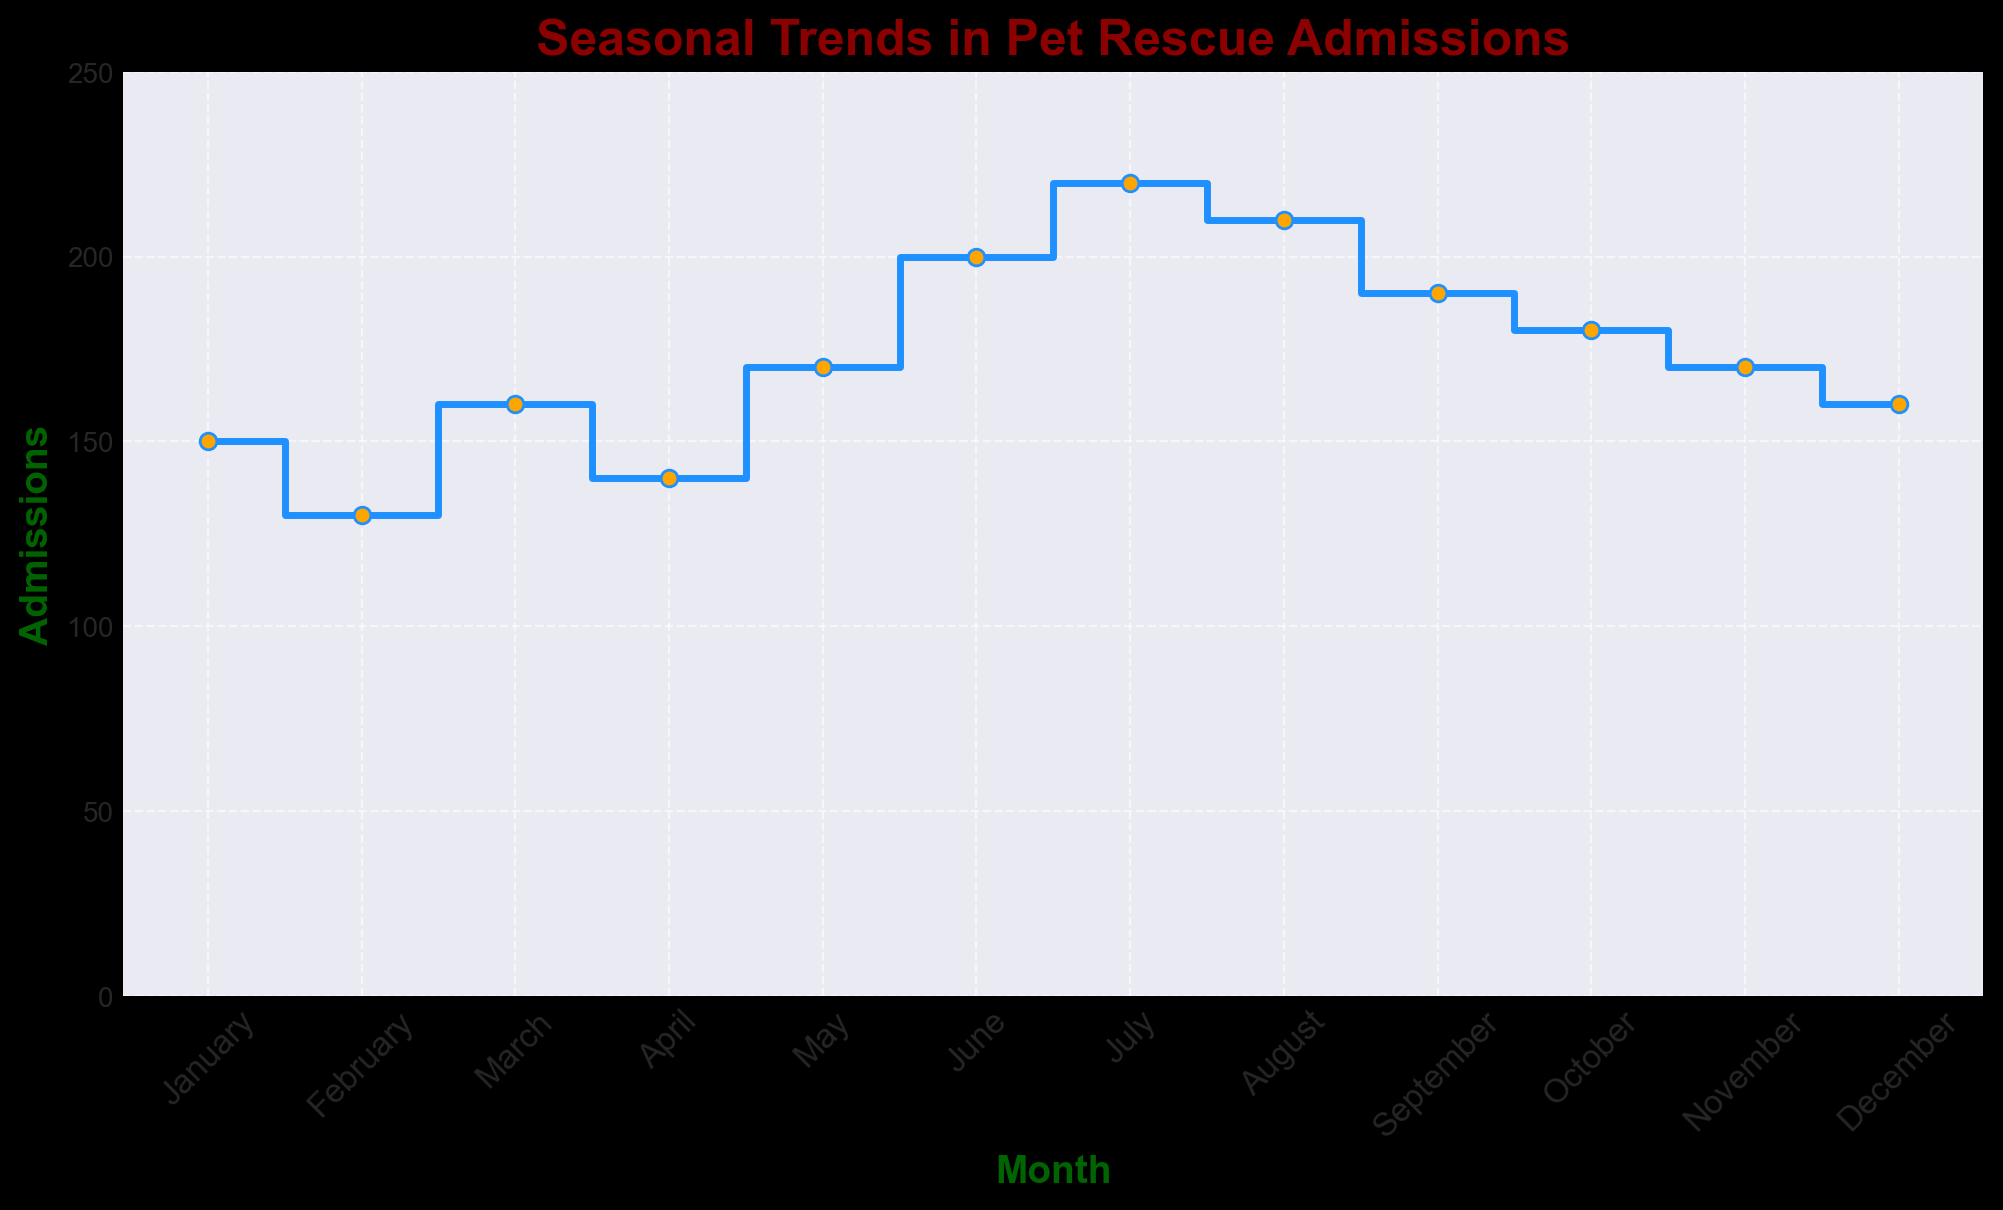Which month has the highest number of pet rescue admissions? We observe the highest point on the stairs plot. July has 220 admissions, making it the highest.
Answer: July Which month has the lowest number of pet rescue admissions? We observe the lowest point on the stairs plot. February has 130 admissions, making it the lowest.
Answer: February How many more admissions were there in March compared to February? Subtract the number of admissions in February from those in March: 160 (March) - 130 (February) = 30.
Answer: 30 What is the average number of pet rescue admissions in the first half of the year (January to June)? Sum the admissions from January to June and divide by 6: (150 + 130 + 160 + 140 + 170 + 200) / 6 = 950 / 6 ≈ 158.33.
Answer: 158.33 Which three consecutive months have the highest total number of pet rescue admissions? Calculate sums for every possible set of three consecutive months and compare them:
(Jan + Feb + Mar) = 150 + 130 + 160 = 440,
(Feb + Mar + Apr) = 130 + 160 + 140 = 430,
(Mar + Apr + May) = 160 + 140 + 170 = 470,
(Apr + May + Jun) = 140 + 170 + 200 = 510,
(May + Jun + Jul) = 170 + 200 + 220 = 590,
(Jun + Jul + Aug) = 200 + 220 + 210 = 630,
(Jul + Aug + Sep) = 220 + 210 + 190 = 620,
(Aug + Sep + Oct) = 210 + 190 + 180 = 580,
(Sep + Oct + Nov) = 190 + 180 + 170 = 540,
(Oct + Nov + Dec) = 180 + 170 + 160 = 510.
The highest total is for Jun, Jul, Aug = 630.
Answer: June, July, August How does the number of admissions in October compare to that in May? October has 180 admissions and May has 170. Comparing the two, 180 - 170 = 10, so October has 10 more admissions.
Answer: 10 more What is the total number of pet rescue admissions for the entire year? Sum the admissions of all months: 150 + 130 + 160 + 140 + 170 + 200 + 220 + 210 + 190 + 180 + 170 + 160 = 2180.
Answer: 2180 Does any month have exactly the same number of admissions as November? November has 170 admissions. May also has 170 admissions, making them equal.
Answer: May Which season (Winter, Spring, Summer, Fall) has the highest total number of admissions? (Winter: Dec-Feb, Spring: Mar-May, Summer: Jun-Aug, Fall: Sep-Nov) Sum the admissions for each season:
Winter: 150 (Jan) + 130 (Feb) + 160 (Dec) = 440,
Spring: 160 (Mar) + 140 (Apr) + 170 (May) = 470,
Summer: 200 (Jun) + 220 (Jul) + 210 (Aug) = 630,
Fall: 190 (Sep) + 180 (Oct) + 170 (Nov) = 540.
Summer has the highest total with 630 admissions.
Answer: Summer In which months do admissions exceed 200? Observing the plot, only June, July, and August exceed 200 admissions.
Answer: June, July, August 